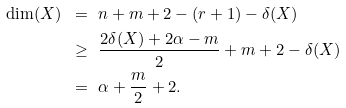Convert formula to latex. <formula><loc_0><loc_0><loc_500><loc_500>\dim ( X ) \ & = \ n + m + 2 - ( r + 1 ) - \delta ( X ) \\ & \geq \ \frac { 2 \delta ( X ) + 2 \alpha - m } { 2 } + m + 2 - \delta ( X ) \\ & = \ \alpha + \frac { m } { 2 } + 2 .</formula> 